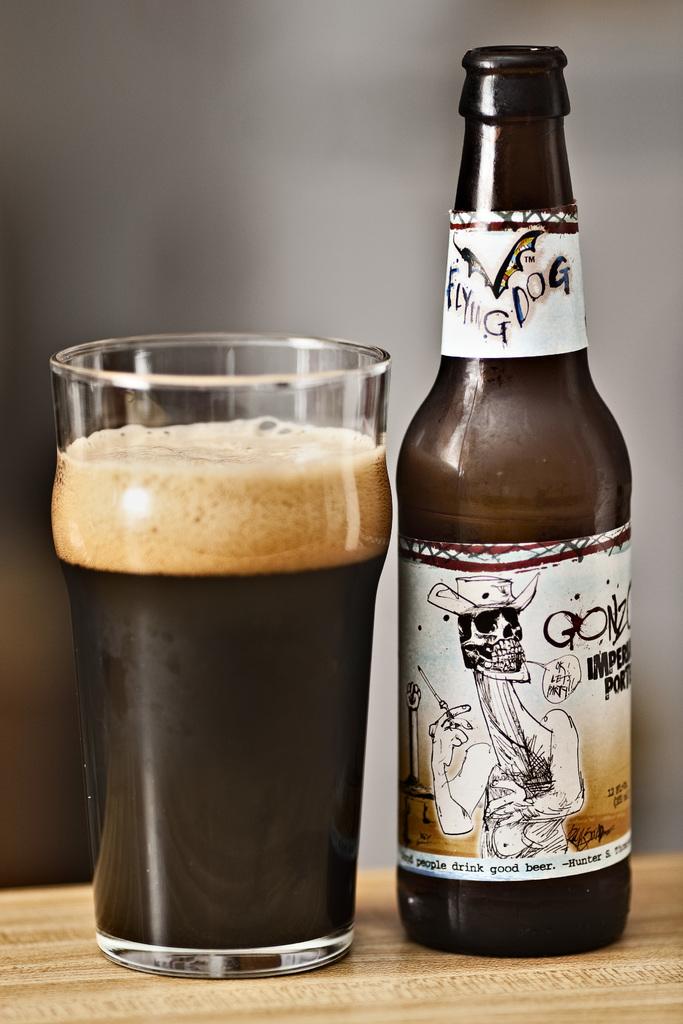What is the volume of this beer?
Provide a short and direct response. Unanswerable. 